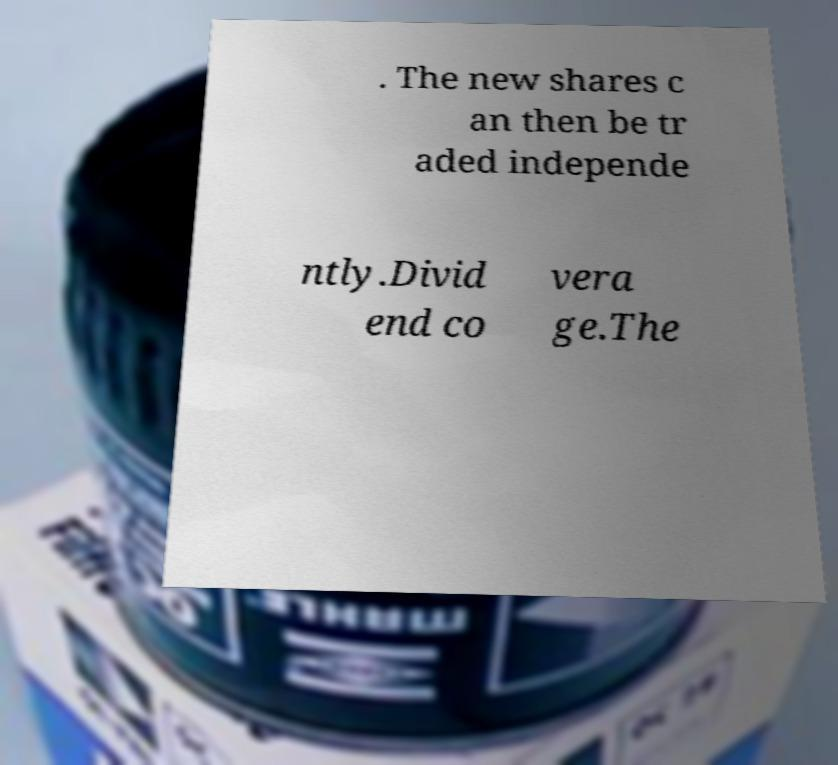For documentation purposes, I need the text within this image transcribed. Could you provide that? . The new shares c an then be tr aded independe ntly.Divid end co vera ge.The 